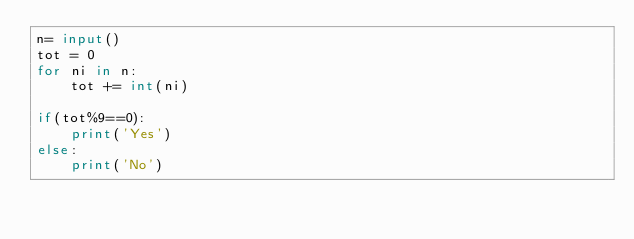<code> <loc_0><loc_0><loc_500><loc_500><_Python_>n= input()
tot = 0
for ni in n:
    tot += int(ni)

if(tot%9==0):
    print('Yes')
else:
    print('No')</code> 